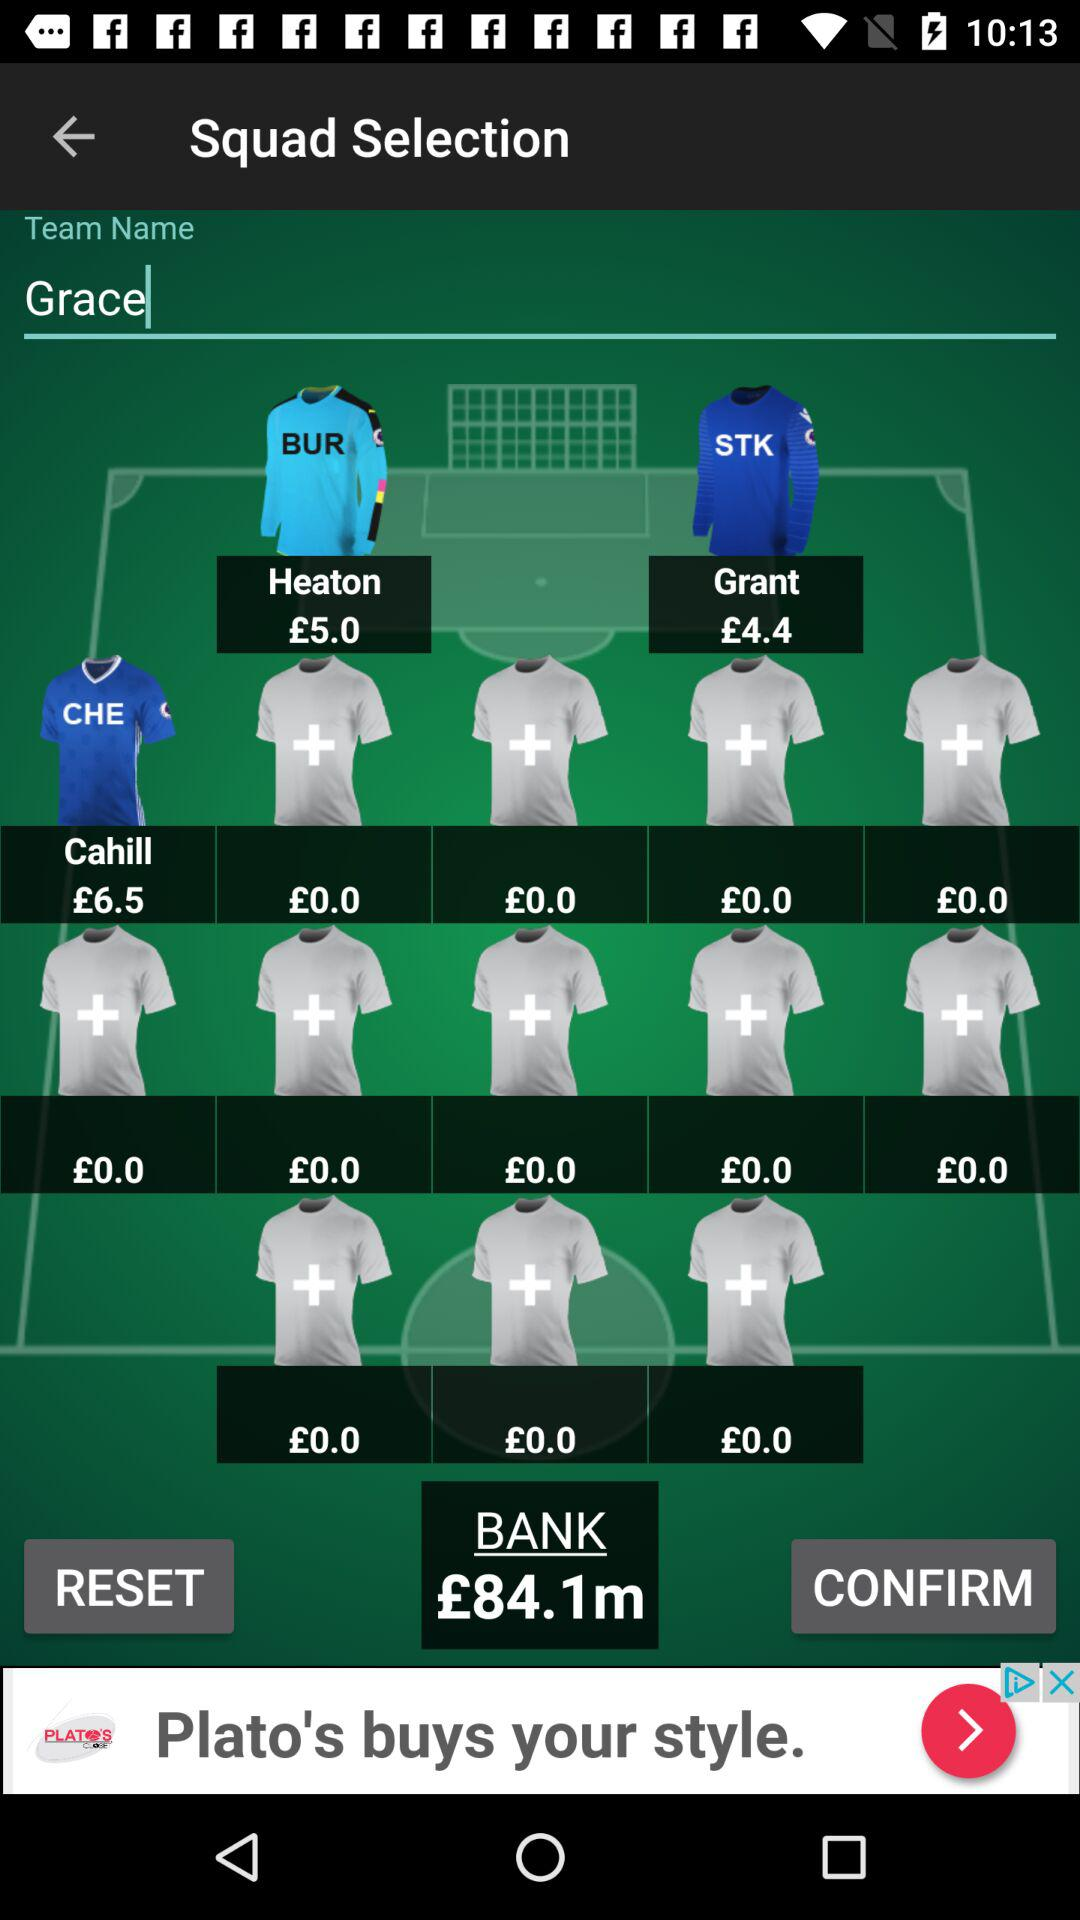What's the cost of heaton? The cost of heaton is £5.0. 